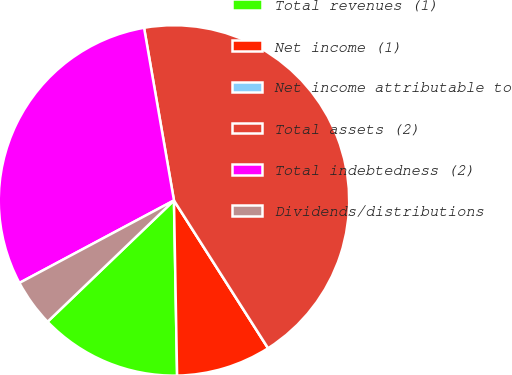<chart> <loc_0><loc_0><loc_500><loc_500><pie_chart><fcel>Total revenues (1)<fcel>Net income (1)<fcel>Net income attributable to<fcel>Total assets (2)<fcel>Total indebtedness (2)<fcel>Dividends/distributions<nl><fcel>13.11%<fcel>8.74%<fcel>0.0%<fcel>43.7%<fcel>30.07%<fcel>4.37%<nl></chart> 